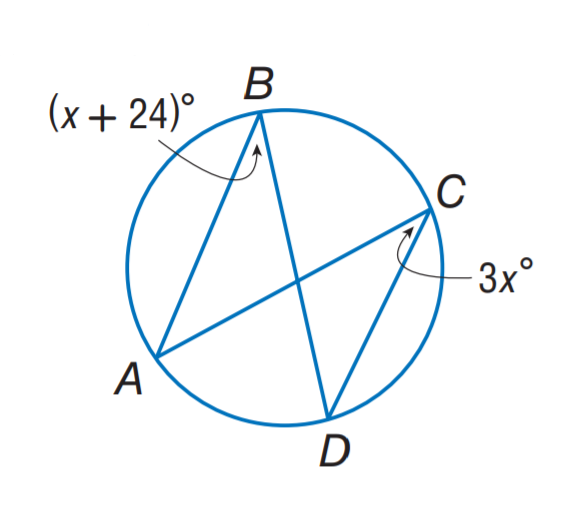Answer the mathemtical geometry problem and directly provide the correct option letter.
Question: Find m \angle B.
Choices: A: 24 B: 36 C: 48 D: 72 B 